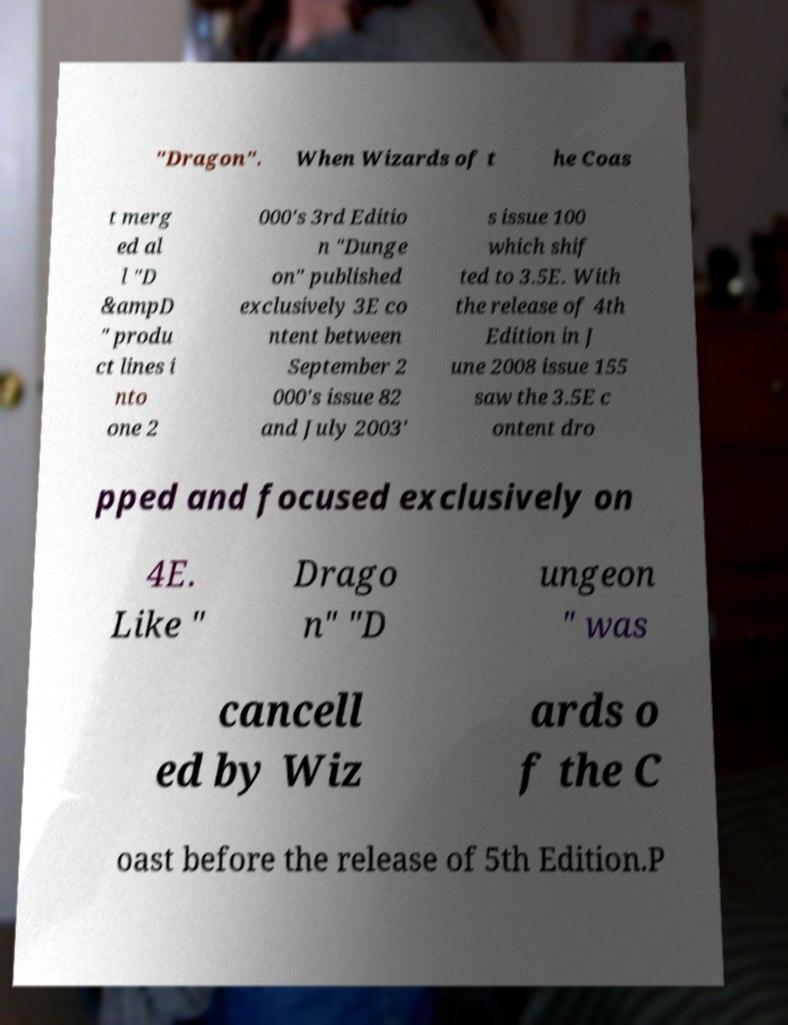For documentation purposes, I need the text within this image transcribed. Could you provide that? "Dragon". When Wizards of t he Coas t merg ed al l "D &ampD " produ ct lines i nto one 2 000's 3rd Editio n "Dunge on" published exclusively 3E co ntent between September 2 000's issue 82 and July 2003' s issue 100 which shif ted to 3.5E. With the release of 4th Edition in J une 2008 issue 155 saw the 3.5E c ontent dro pped and focused exclusively on 4E. Like " Drago n" "D ungeon " was cancell ed by Wiz ards o f the C oast before the release of 5th Edition.P 